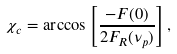Convert formula to latex. <formula><loc_0><loc_0><loc_500><loc_500>\chi _ { c } = \arccos \left [ \frac { - F ( 0 ) } { 2 F _ { R } ( \nu _ { p } ) } \right ] ,</formula> 